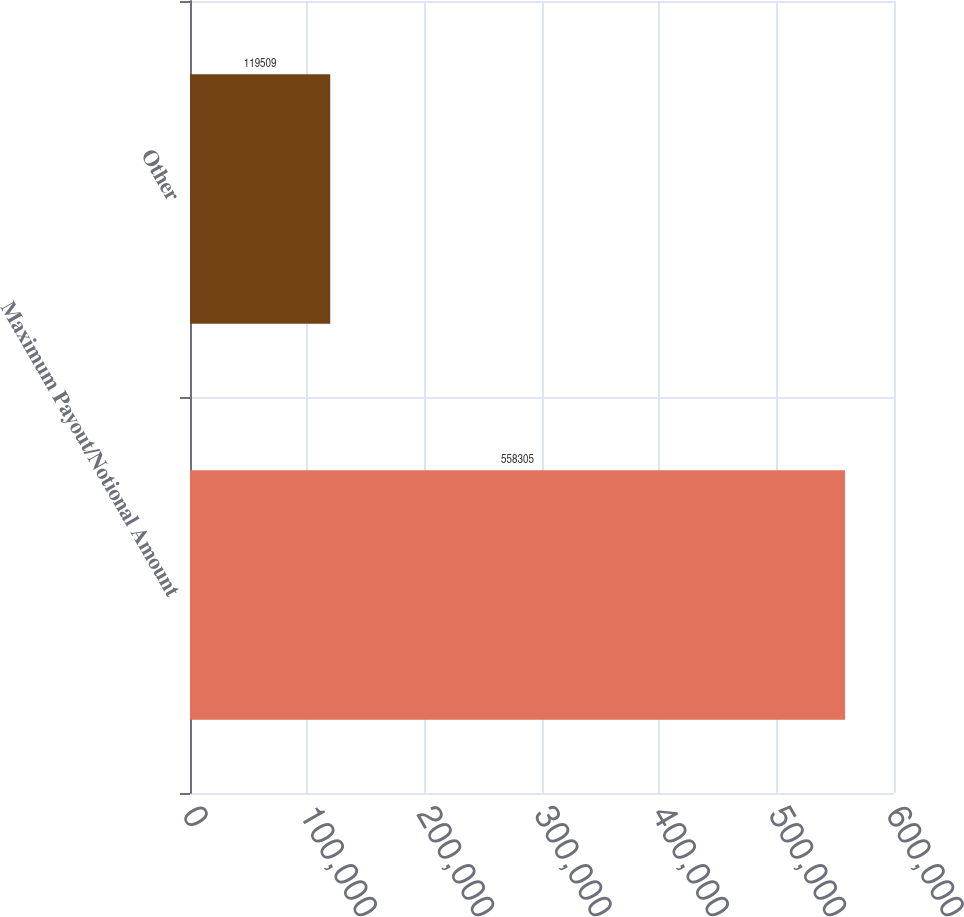Convert chart to OTSL. <chart><loc_0><loc_0><loc_500><loc_500><bar_chart><fcel>Maximum Payout/Notional Amount<fcel>Other<nl><fcel>558305<fcel>119509<nl></chart> 